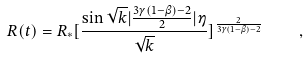Convert formula to latex. <formula><loc_0><loc_0><loc_500><loc_500>R ( t ) = R _ { * } [ \frac { \sin { \sqrt { k } | \frac { 3 \gamma ( 1 - \beta ) - 2 } { 2 } | \eta } } { \sqrt { k } } ] ^ { \frac { 2 } { 3 \gamma ( 1 - \beta ) - 2 } } \quad ,</formula> 